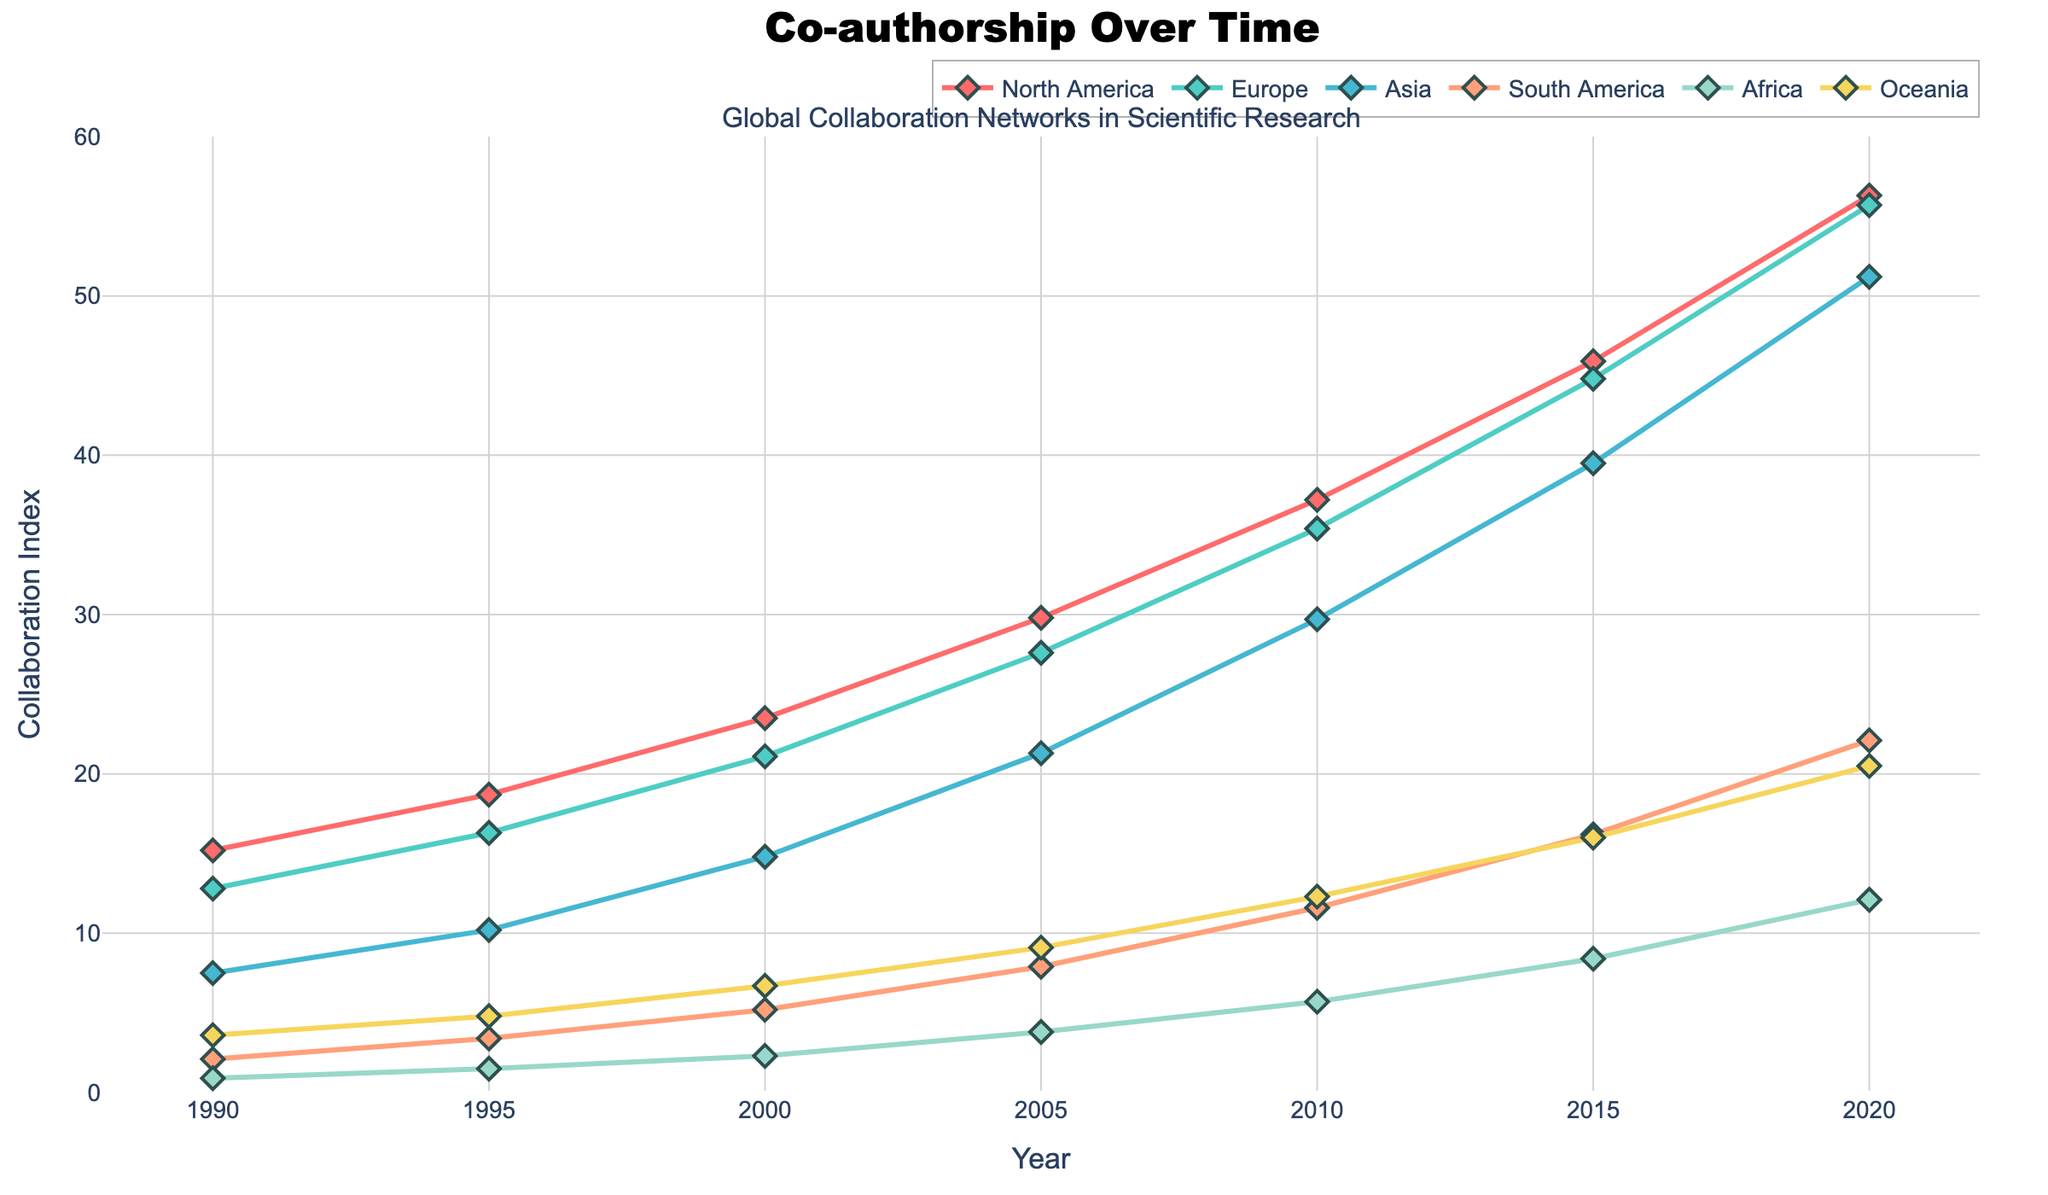Which region has the highest collaboration index in 2020? By looking at the plot, the line representing North America reaches the highest point in 2020 compared to other regions.
Answer: North America How much did the collaboration index for Asia increase from 1990 to 2020? In 1990, the collaboration index for Asia was 7.5, and in 2020 it was 51.2. The increase is calculated as 51.2 - 7.5 = 43.7
Answer: 43.7 Which region had the lowest collaboration index in 1990, and what was it? The region with the lowest line marker in 1990 is Africa, with a collaboration index of 0.9
Answer: Africa, 0.9 What is the average collaboration index for Europe over the time period 1990 to 2020? To find the average, sum the collaboration indices for Europe from 1990 to 2020 and divide by the number of data points: (12.8 + 16.3 + 21.1 + 27.6 + 35.4 + 44.8 + 55.7) / 7 = 30.5
Answer: 30.5 Which regions show a consistent increasing trend in collaboration index over time? By observing the plot, all regions (North America, Europe, Asia, South America, Africa, Oceania) show a consistent increase in their collaboration indices over the years.
Answer: All regions By how much did the collaboration index for South America increase from 2000 to 2005? The collaboration index for South America in 2000 was 5.2, and in 2005 it was 7.9. The increase is 7.9 - 5.2 = 2.7
Answer: 2.7 In which year did Oceania first surpass a collaboration index of 10? By examining the plot for Oceania, it first surpasses the collaboration index of 10 in 2010 with a value of 12.3.
Answer: 2010 Compare the collaboration indices of Africa and Oceania in 2015. Which region had a higher value and by how much? In 2015, Africa's collaboration index was 8.4 and Oceania's was 16.0. Oceania had a higher value by 16.0 - 8.4 = 7.6.
Answer: Oceania by 7.6 What is the range of the collaboration index for North America from 1990 to 2020? The range is the difference between the highest and lowest values. For North America, the highest value is 56.3 in 2020 and the lowest is 15.2 in 1990. The range is 56.3 - 15.2 = 41.1.
Answer: 41.1 What is the total increase in collaboration index for all regions from 1990 to 2020? Sum the increase for each region: North America: 56.3 - 15.2 = 41.1, Europe: 55.7 - 12.8 = 42.9, Asia: 51.2 - 7.5 = 43.7, South America: 22.1 - 2.1 = 20.0, Africa: 12.1 - 0.9 = 11.2, Oceania: 20.5 - 3.6 = 16.9. Total increase: 41.1 + 42.9 + 43.7 + 20.0 + 11.2 + 16.9 = 175.8.
Answer: 175.8 